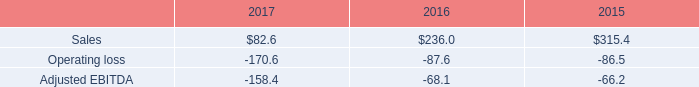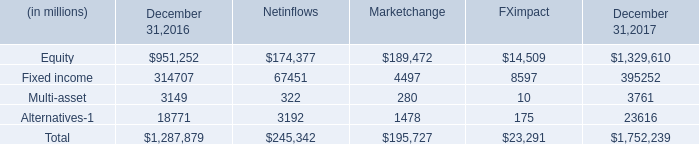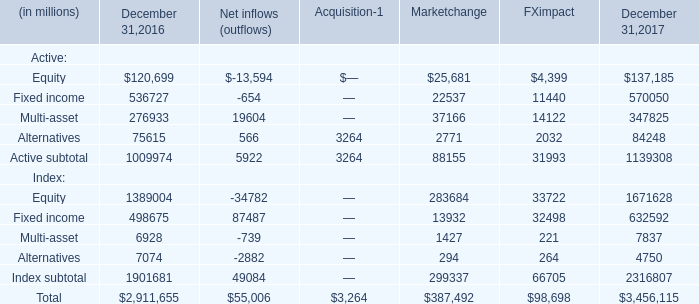What's the sum of Equity and Fixed income in 2016? (in million) 
Computations: (951252 + 314707)
Answer: 1265959.0. 